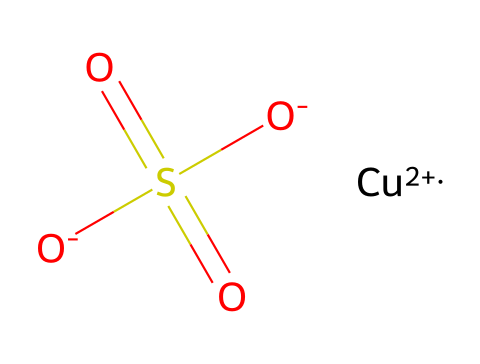What is the central metal ion in this structure? The structure contains a copper ion indicated by the "[Cu+2]" in the SMILES representation, which shows it as a central metal ion with a +2 oxidation state.
Answer: copper How many oxygen atoms are present in this chemical? By examining the SMILES notation, there are four oxygen atoms connected to the sulfur and involved in the sulfate group, implied by "O" in the structure along with two "O-" and the double bond "O" near S.
Answer: four What type of bonding is primarily present in copper sulfate? The diagram reflects ionic bonding, especially between the copper ion and the sulfate group, where the cation (Cu+2) interacts with the negatively charged sulfate (SO4).
Answer: ionic What functional group is present in this chemical? The presence of the "S(=O)(=O)[O-]" indicates a sulfate group (SO4), characterized by sulfur double-bonded to two oxygens and single-bonded to another oxygen which carries a negative charge.
Answer: sulfate How does copper sulfate function as a fungicide? Copper sulfate disrupts fungal cell walls and interferes with enzyme activity, effectively killing or inhibiting the growth of fungi due to its ability to release Cu ions, which are toxic to many microorganisms.
Answer: disrupts cell walls What is the total charge of the copper sulfate molecule in its common form? The copper ion has a +2 charge (Cu+2) and the sulfate has a combined charge of -2, leading to the overall molecule being neutral when combined, as the charges cancel each other out.
Answer: neutral 